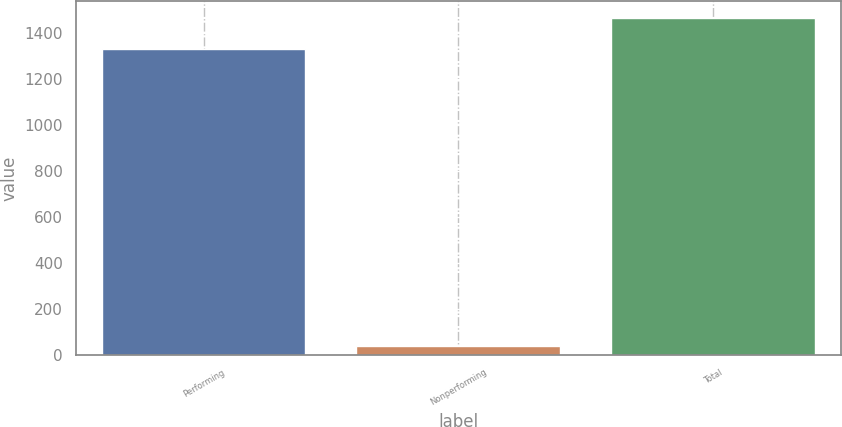Convert chart to OTSL. <chart><loc_0><loc_0><loc_500><loc_500><bar_chart><fcel>Performing<fcel>Nonperforming<fcel>Total<nl><fcel>1331.5<fcel>36.4<fcel>1464.65<nl></chart> 